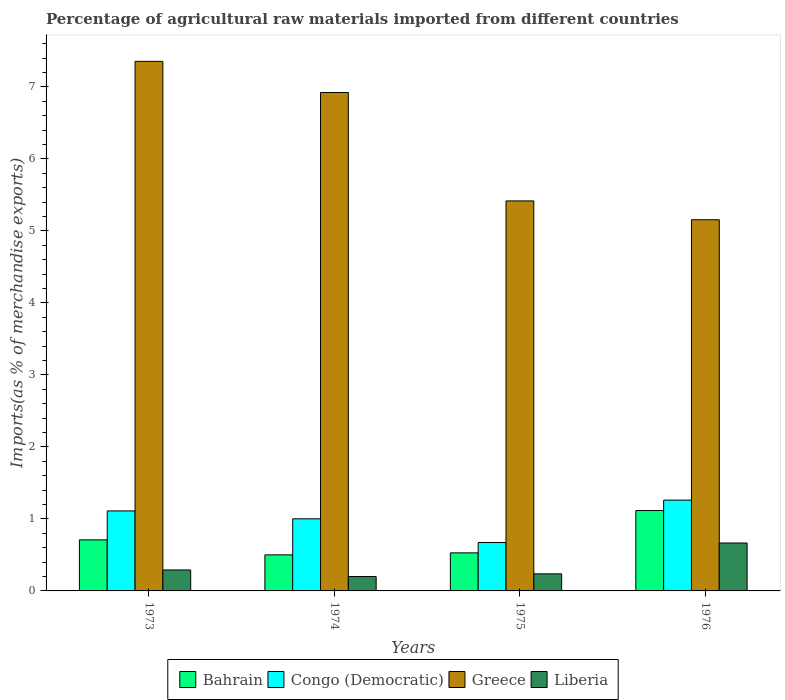How many different coloured bars are there?
Offer a very short reply. 4. Are the number of bars on each tick of the X-axis equal?
Offer a terse response. Yes. How many bars are there on the 1st tick from the left?
Ensure brevity in your answer.  4. In how many cases, is the number of bars for a given year not equal to the number of legend labels?
Provide a succinct answer. 0. What is the percentage of imports to different countries in Greece in 1973?
Your answer should be very brief. 7.35. Across all years, what is the maximum percentage of imports to different countries in Greece?
Give a very brief answer. 7.35. Across all years, what is the minimum percentage of imports to different countries in Bahrain?
Give a very brief answer. 0.5. In which year was the percentage of imports to different countries in Liberia maximum?
Your response must be concise. 1976. In which year was the percentage of imports to different countries in Liberia minimum?
Your answer should be very brief. 1974. What is the total percentage of imports to different countries in Congo (Democratic) in the graph?
Ensure brevity in your answer.  4.05. What is the difference between the percentage of imports to different countries in Liberia in 1973 and that in 1976?
Provide a short and direct response. -0.37. What is the difference between the percentage of imports to different countries in Congo (Democratic) in 1975 and the percentage of imports to different countries in Liberia in 1974?
Make the answer very short. 0.47. What is the average percentage of imports to different countries in Greece per year?
Give a very brief answer. 6.21. In the year 1976, what is the difference between the percentage of imports to different countries in Bahrain and percentage of imports to different countries in Liberia?
Make the answer very short. 0.45. In how many years, is the percentage of imports to different countries in Congo (Democratic) greater than 2.8 %?
Offer a very short reply. 0. What is the ratio of the percentage of imports to different countries in Congo (Democratic) in 1973 to that in 1976?
Provide a short and direct response. 0.88. What is the difference between the highest and the second highest percentage of imports to different countries in Congo (Democratic)?
Make the answer very short. 0.15. What is the difference between the highest and the lowest percentage of imports to different countries in Bahrain?
Ensure brevity in your answer.  0.62. Is the sum of the percentage of imports to different countries in Greece in 1973 and 1976 greater than the maximum percentage of imports to different countries in Liberia across all years?
Give a very brief answer. Yes. Is it the case that in every year, the sum of the percentage of imports to different countries in Greece and percentage of imports to different countries in Liberia is greater than the sum of percentage of imports to different countries in Bahrain and percentage of imports to different countries in Congo (Democratic)?
Your answer should be compact. Yes. What does the 2nd bar from the left in 1976 represents?
Make the answer very short. Congo (Democratic). What does the 1st bar from the right in 1973 represents?
Ensure brevity in your answer.  Liberia. How many bars are there?
Your response must be concise. 16. Are all the bars in the graph horizontal?
Your response must be concise. No. What is the difference between two consecutive major ticks on the Y-axis?
Your answer should be compact. 1. Does the graph contain any zero values?
Ensure brevity in your answer.  No. Does the graph contain grids?
Your response must be concise. No. How many legend labels are there?
Keep it short and to the point. 4. What is the title of the graph?
Ensure brevity in your answer.  Percentage of agricultural raw materials imported from different countries. What is the label or title of the X-axis?
Make the answer very short. Years. What is the label or title of the Y-axis?
Your response must be concise. Imports(as % of merchandise exports). What is the Imports(as % of merchandise exports) in Bahrain in 1973?
Offer a terse response. 0.71. What is the Imports(as % of merchandise exports) of Congo (Democratic) in 1973?
Make the answer very short. 1.11. What is the Imports(as % of merchandise exports) of Greece in 1973?
Offer a very short reply. 7.35. What is the Imports(as % of merchandise exports) of Liberia in 1973?
Your answer should be very brief. 0.29. What is the Imports(as % of merchandise exports) of Bahrain in 1974?
Offer a terse response. 0.5. What is the Imports(as % of merchandise exports) in Congo (Democratic) in 1974?
Make the answer very short. 1. What is the Imports(as % of merchandise exports) of Greece in 1974?
Your response must be concise. 6.92. What is the Imports(as % of merchandise exports) of Liberia in 1974?
Your answer should be very brief. 0.2. What is the Imports(as % of merchandise exports) of Bahrain in 1975?
Your response must be concise. 0.53. What is the Imports(as % of merchandise exports) in Congo (Democratic) in 1975?
Ensure brevity in your answer.  0.67. What is the Imports(as % of merchandise exports) of Greece in 1975?
Offer a terse response. 5.42. What is the Imports(as % of merchandise exports) in Liberia in 1975?
Keep it short and to the point. 0.24. What is the Imports(as % of merchandise exports) of Bahrain in 1976?
Make the answer very short. 1.12. What is the Imports(as % of merchandise exports) of Congo (Democratic) in 1976?
Make the answer very short. 1.26. What is the Imports(as % of merchandise exports) in Greece in 1976?
Your answer should be compact. 5.15. What is the Imports(as % of merchandise exports) of Liberia in 1976?
Give a very brief answer. 0.67. Across all years, what is the maximum Imports(as % of merchandise exports) of Bahrain?
Offer a very short reply. 1.12. Across all years, what is the maximum Imports(as % of merchandise exports) in Congo (Democratic)?
Make the answer very short. 1.26. Across all years, what is the maximum Imports(as % of merchandise exports) of Greece?
Provide a succinct answer. 7.35. Across all years, what is the maximum Imports(as % of merchandise exports) in Liberia?
Give a very brief answer. 0.67. Across all years, what is the minimum Imports(as % of merchandise exports) of Bahrain?
Provide a succinct answer. 0.5. Across all years, what is the minimum Imports(as % of merchandise exports) of Congo (Democratic)?
Offer a terse response. 0.67. Across all years, what is the minimum Imports(as % of merchandise exports) in Greece?
Give a very brief answer. 5.15. Across all years, what is the minimum Imports(as % of merchandise exports) in Liberia?
Offer a very short reply. 0.2. What is the total Imports(as % of merchandise exports) of Bahrain in the graph?
Give a very brief answer. 2.85. What is the total Imports(as % of merchandise exports) in Congo (Democratic) in the graph?
Your answer should be very brief. 4.05. What is the total Imports(as % of merchandise exports) of Greece in the graph?
Offer a terse response. 24.85. What is the total Imports(as % of merchandise exports) of Liberia in the graph?
Provide a short and direct response. 1.39. What is the difference between the Imports(as % of merchandise exports) in Bahrain in 1973 and that in 1974?
Your answer should be very brief. 0.21. What is the difference between the Imports(as % of merchandise exports) in Congo (Democratic) in 1973 and that in 1974?
Keep it short and to the point. 0.11. What is the difference between the Imports(as % of merchandise exports) of Greece in 1973 and that in 1974?
Your response must be concise. 0.43. What is the difference between the Imports(as % of merchandise exports) in Liberia in 1973 and that in 1974?
Your answer should be very brief. 0.09. What is the difference between the Imports(as % of merchandise exports) of Bahrain in 1973 and that in 1975?
Your answer should be compact. 0.18. What is the difference between the Imports(as % of merchandise exports) of Congo (Democratic) in 1973 and that in 1975?
Give a very brief answer. 0.44. What is the difference between the Imports(as % of merchandise exports) in Greece in 1973 and that in 1975?
Keep it short and to the point. 1.94. What is the difference between the Imports(as % of merchandise exports) of Liberia in 1973 and that in 1975?
Offer a terse response. 0.05. What is the difference between the Imports(as % of merchandise exports) in Bahrain in 1973 and that in 1976?
Provide a short and direct response. -0.41. What is the difference between the Imports(as % of merchandise exports) in Congo (Democratic) in 1973 and that in 1976?
Provide a short and direct response. -0.15. What is the difference between the Imports(as % of merchandise exports) in Greece in 1973 and that in 1976?
Your answer should be compact. 2.2. What is the difference between the Imports(as % of merchandise exports) in Liberia in 1973 and that in 1976?
Offer a terse response. -0.37. What is the difference between the Imports(as % of merchandise exports) in Bahrain in 1974 and that in 1975?
Provide a succinct answer. -0.03. What is the difference between the Imports(as % of merchandise exports) in Congo (Democratic) in 1974 and that in 1975?
Provide a short and direct response. 0.33. What is the difference between the Imports(as % of merchandise exports) of Greece in 1974 and that in 1975?
Keep it short and to the point. 1.51. What is the difference between the Imports(as % of merchandise exports) in Liberia in 1974 and that in 1975?
Offer a very short reply. -0.04. What is the difference between the Imports(as % of merchandise exports) in Bahrain in 1974 and that in 1976?
Your response must be concise. -0.62. What is the difference between the Imports(as % of merchandise exports) of Congo (Democratic) in 1974 and that in 1976?
Ensure brevity in your answer.  -0.26. What is the difference between the Imports(as % of merchandise exports) in Greece in 1974 and that in 1976?
Make the answer very short. 1.77. What is the difference between the Imports(as % of merchandise exports) of Liberia in 1974 and that in 1976?
Offer a very short reply. -0.47. What is the difference between the Imports(as % of merchandise exports) of Bahrain in 1975 and that in 1976?
Make the answer very short. -0.59. What is the difference between the Imports(as % of merchandise exports) of Congo (Democratic) in 1975 and that in 1976?
Make the answer very short. -0.59. What is the difference between the Imports(as % of merchandise exports) of Greece in 1975 and that in 1976?
Offer a terse response. 0.26. What is the difference between the Imports(as % of merchandise exports) in Liberia in 1975 and that in 1976?
Provide a short and direct response. -0.43. What is the difference between the Imports(as % of merchandise exports) in Bahrain in 1973 and the Imports(as % of merchandise exports) in Congo (Democratic) in 1974?
Your answer should be compact. -0.29. What is the difference between the Imports(as % of merchandise exports) in Bahrain in 1973 and the Imports(as % of merchandise exports) in Greece in 1974?
Your response must be concise. -6.21. What is the difference between the Imports(as % of merchandise exports) of Bahrain in 1973 and the Imports(as % of merchandise exports) of Liberia in 1974?
Your answer should be compact. 0.51. What is the difference between the Imports(as % of merchandise exports) of Congo (Democratic) in 1973 and the Imports(as % of merchandise exports) of Greece in 1974?
Make the answer very short. -5.81. What is the difference between the Imports(as % of merchandise exports) of Congo (Democratic) in 1973 and the Imports(as % of merchandise exports) of Liberia in 1974?
Provide a succinct answer. 0.91. What is the difference between the Imports(as % of merchandise exports) of Greece in 1973 and the Imports(as % of merchandise exports) of Liberia in 1974?
Give a very brief answer. 7.15. What is the difference between the Imports(as % of merchandise exports) in Bahrain in 1973 and the Imports(as % of merchandise exports) in Congo (Democratic) in 1975?
Provide a succinct answer. 0.04. What is the difference between the Imports(as % of merchandise exports) in Bahrain in 1973 and the Imports(as % of merchandise exports) in Greece in 1975?
Provide a short and direct response. -4.71. What is the difference between the Imports(as % of merchandise exports) of Bahrain in 1973 and the Imports(as % of merchandise exports) of Liberia in 1975?
Give a very brief answer. 0.47. What is the difference between the Imports(as % of merchandise exports) in Congo (Democratic) in 1973 and the Imports(as % of merchandise exports) in Greece in 1975?
Ensure brevity in your answer.  -4.31. What is the difference between the Imports(as % of merchandise exports) of Congo (Democratic) in 1973 and the Imports(as % of merchandise exports) of Liberia in 1975?
Keep it short and to the point. 0.87. What is the difference between the Imports(as % of merchandise exports) in Greece in 1973 and the Imports(as % of merchandise exports) in Liberia in 1975?
Offer a terse response. 7.12. What is the difference between the Imports(as % of merchandise exports) in Bahrain in 1973 and the Imports(as % of merchandise exports) in Congo (Democratic) in 1976?
Provide a succinct answer. -0.55. What is the difference between the Imports(as % of merchandise exports) of Bahrain in 1973 and the Imports(as % of merchandise exports) of Greece in 1976?
Provide a short and direct response. -4.45. What is the difference between the Imports(as % of merchandise exports) of Bahrain in 1973 and the Imports(as % of merchandise exports) of Liberia in 1976?
Your response must be concise. 0.04. What is the difference between the Imports(as % of merchandise exports) of Congo (Democratic) in 1973 and the Imports(as % of merchandise exports) of Greece in 1976?
Keep it short and to the point. -4.04. What is the difference between the Imports(as % of merchandise exports) in Congo (Democratic) in 1973 and the Imports(as % of merchandise exports) in Liberia in 1976?
Make the answer very short. 0.45. What is the difference between the Imports(as % of merchandise exports) of Greece in 1973 and the Imports(as % of merchandise exports) of Liberia in 1976?
Provide a succinct answer. 6.69. What is the difference between the Imports(as % of merchandise exports) of Bahrain in 1974 and the Imports(as % of merchandise exports) of Congo (Democratic) in 1975?
Provide a succinct answer. -0.17. What is the difference between the Imports(as % of merchandise exports) of Bahrain in 1974 and the Imports(as % of merchandise exports) of Greece in 1975?
Offer a very short reply. -4.92. What is the difference between the Imports(as % of merchandise exports) in Bahrain in 1974 and the Imports(as % of merchandise exports) in Liberia in 1975?
Keep it short and to the point. 0.26. What is the difference between the Imports(as % of merchandise exports) in Congo (Democratic) in 1974 and the Imports(as % of merchandise exports) in Greece in 1975?
Your response must be concise. -4.41. What is the difference between the Imports(as % of merchandise exports) of Congo (Democratic) in 1974 and the Imports(as % of merchandise exports) of Liberia in 1975?
Make the answer very short. 0.76. What is the difference between the Imports(as % of merchandise exports) in Greece in 1974 and the Imports(as % of merchandise exports) in Liberia in 1975?
Offer a terse response. 6.68. What is the difference between the Imports(as % of merchandise exports) in Bahrain in 1974 and the Imports(as % of merchandise exports) in Congo (Democratic) in 1976?
Offer a very short reply. -0.76. What is the difference between the Imports(as % of merchandise exports) of Bahrain in 1974 and the Imports(as % of merchandise exports) of Greece in 1976?
Your response must be concise. -4.65. What is the difference between the Imports(as % of merchandise exports) of Bahrain in 1974 and the Imports(as % of merchandise exports) of Liberia in 1976?
Keep it short and to the point. -0.16. What is the difference between the Imports(as % of merchandise exports) of Congo (Democratic) in 1974 and the Imports(as % of merchandise exports) of Greece in 1976?
Your answer should be very brief. -4.15. What is the difference between the Imports(as % of merchandise exports) of Congo (Democratic) in 1974 and the Imports(as % of merchandise exports) of Liberia in 1976?
Provide a short and direct response. 0.34. What is the difference between the Imports(as % of merchandise exports) in Greece in 1974 and the Imports(as % of merchandise exports) in Liberia in 1976?
Ensure brevity in your answer.  6.26. What is the difference between the Imports(as % of merchandise exports) of Bahrain in 1975 and the Imports(as % of merchandise exports) of Congo (Democratic) in 1976?
Provide a short and direct response. -0.73. What is the difference between the Imports(as % of merchandise exports) of Bahrain in 1975 and the Imports(as % of merchandise exports) of Greece in 1976?
Your answer should be very brief. -4.63. What is the difference between the Imports(as % of merchandise exports) in Bahrain in 1975 and the Imports(as % of merchandise exports) in Liberia in 1976?
Offer a terse response. -0.14. What is the difference between the Imports(as % of merchandise exports) in Congo (Democratic) in 1975 and the Imports(as % of merchandise exports) in Greece in 1976?
Ensure brevity in your answer.  -4.48. What is the difference between the Imports(as % of merchandise exports) of Congo (Democratic) in 1975 and the Imports(as % of merchandise exports) of Liberia in 1976?
Make the answer very short. 0.01. What is the difference between the Imports(as % of merchandise exports) in Greece in 1975 and the Imports(as % of merchandise exports) in Liberia in 1976?
Offer a very short reply. 4.75. What is the average Imports(as % of merchandise exports) of Bahrain per year?
Give a very brief answer. 0.71. What is the average Imports(as % of merchandise exports) of Congo (Democratic) per year?
Offer a very short reply. 1.01. What is the average Imports(as % of merchandise exports) in Greece per year?
Provide a short and direct response. 6.21. What is the average Imports(as % of merchandise exports) in Liberia per year?
Ensure brevity in your answer.  0.35. In the year 1973, what is the difference between the Imports(as % of merchandise exports) in Bahrain and Imports(as % of merchandise exports) in Congo (Democratic)?
Keep it short and to the point. -0.4. In the year 1973, what is the difference between the Imports(as % of merchandise exports) of Bahrain and Imports(as % of merchandise exports) of Greece?
Your response must be concise. -6.65. In the year 1973, what is the difference between the Imports(as % of merchandise exports) of Bahrain and Imports(as % of merchandise exports) of Liberia?
Make the answer very short. 0.42. In the year 1973, what is the difference between the Imports(as % of merchandise exports) of Congo (Democratic) and Imports(as % of merchandise exports) of Greece?
Give a very brief answer. -6.24. In the year 1973, what is the difference between the Imports(as % of merchandise exports) of Congo (Democratic) and Imports(as % of merchandise exports) of Liberia?
Your answer should be very brief. 0.82. In the year 1973, what is the difference between the Imports(as % of merchandise exports) of Greece and Imports(as % of merchandise exports) of Liberia?
Your response must be concise. 7.06. In the year 1974, what is the difference between the Imports(as % of merchandise exports) of Bahrain and Imports(as % of merchandise exports) of Congo (Democratic)?
Your answer should be compact. -0.5. In the year 1974, what is the difference between the Imports(as % of merchandise exports) in Bahrain and Imports(as % of merchandise exports) in Greece?
Your answer should be compact. -6.42. In the year 1974, what is the difference between the Imports(as % of merchandise exports) of Bahrain and Imports(as % of merchandise exports) of Liberia?
Offer a very short reply. 0.3. In the year 1974, what is the difference between the Imports(as % of merchandise exports) in Congo (Democratic) and Imports(as % of merchandise exports) in Greece?
Provide a succinct answer. -5.92. In the year 1974, what is the difference between the Imports(as % of merchandise exports) of Congo (Democratic) and Imports(as % of merchandise exports) of Liberia?
Your answer should be compact. 0.8. In the year 1974, what is the difference between the Imports(as % of merchandise exports) of Greece and Imports(as % of merchandise exports) of Liberia?
Make the answer very short. 6.72. In the year 1975, what is the difference between the Imports(as % of merchandise exports) of Bahrain and Imports(as % of merchandise exports) of Congo (Democratic)?
Give a very brief answer. -0.14. In the year 1975, what is the difference between the Imports(as % of merchandise exports) of Bahrain and Imports(as % of merchandise exports) of Greece?
Make the answer very short. -4.89. In the year 1975, what is the difference between the Imports(as % of merchandise exports) in Bahrain and Imports(as % of merchandise exports) in Liberia?
Provide a succinct answer. 0.29. In the year 1975, what is the difference between the Imports(as % of merchandise exports) of Congo (Democratic) and Imports(as % of merchandise exports) of Greece?
Your answer should be compact. -4.74. In the year 1975, what is the difference between the Imports(as % of merchandise exports) of Congo (Democratic) and Imports(as % of merchandise exports) of Liberia?
Offer a very short reply. 0.44. In the year 1975, what is the difference between the Imports(as % of merchandise exports) of Greece and Imports(as % of merchandise exports) of Liberia?
Offer a very short reply. 5.18. In the year 1976, what is the difference between the Imports(as % of merchandise exports) of Bahrain and Imports(as % of merchandise exports) of Congo (Democratic)?
Offer a very short reply. -0.14. In the year 1976, what is the difference between the Imports(as % of merchandise exports) in Bahrain and Imports(as % of merchandise exports) in Greece?
Provide a succinct answer. -4.04. In the year 1976, what is the difference between the Imports(as % of merchandise exports) in Bahrain and Imports(as % of merchandise exports) in Liberia?
Offer a very short reply. 0.45. In the year 1976, what is the difference between the Imports(as % of merchandise exports) in Congo (Democratic) and Imports(as % of merchandise exports) in Greece?
Your answer should be very brief. -3.89. In the year 1976, what is the difference between the Imports(as % of merchandise exports) in Congo (Democratic) and Imports(as % of merchandise exports) in Liberia?
Give a very brief answer. 0.6. In the year 1976, what is the difference between the Imports(as % of merchandise exports) in Greece and Imports(as % of merchandise exports) in Liberia?
Provide a succinct answer. 4.49. What is the ratio of the Imports(as % of merchandise exports) of Bahrain in 1973 to that in 1974?
Your answer should be compact. 1.42. What is the ratio of the Imports(as % of merchandise exports) in Congo (Democratic) in 1973 to that in 1974?
Offer a very short reply. 1.11. What is the ratio of the Imports(as % of merchandise exports) in Liberia in 1973 to that in 1974?
Offer a very short reply. 1.46. What is the ratio of the Imports(as % of merchandise exports) in Bahrain in 1973 to that in 1975?
Provide a short and direct response. 1.34. What is the ratio of the Imports(as % of merchandise exports) of Congo (Democratic) in 1973 to that in 1975?
Offer a very short reply. 1.65. What is the ratio of the Imports(as % of merchandise exports) of Greece in 1973 to that in 1975?
Offer a very short reply. 1.36. What is the ratio of the Imports(as % of merchandise exports) in Liberia in 1973 to that in 1975?
Your answer should be very brief. 1.23. What is the ratio of the Imports(as % of merchandise exports) in Bahrain in 1973 to that in 1976?
Offer a terse response. 0.64. What is the ratio of the Imports(as % of merchandise exports) in Congo (Democratic) in 1973 to that in 1976?
Provide a succinct answer. 0.88. What is the ratio of the Imports(as % of merchandise exports) of Greece in 1973 to that in 1976?
Keep it short and to the point. 1.43. What is the ratio of the Imports(as % of merchandise exports) in Liberia in 1973 to that in 1976?
Offer a terse response. 0.44. What is the ratio of the Imports(as % of merchandise exports) of Bahrain in 1974 to that in 1975?
Give a very brief answer. 0.95. What is the ratio of the Imports(as % of merchandise exports) in Congo (Democratic) in 1974 to that in 1975?
Your answer should be compact. 1.49. What is the ratio of the Imports(as % of merchandise exports) in Greece in 1974 to that in 1975?
Provide a succinct answer. 1.28. What is the ratio of the Imports(as % of merchandise exports) in Liberia in 1974 to that in 1975?
Your answer should be very brief. 0.84. What is the ratio of the Imports(as % of merchandise exports) of Bahrain in 1974 to that in 1976?
Make the answer very short. 0.45. What is the ratio of the Imports(as % of merchandise exports) of Congo (Democratic) in 1974 to that in 1976?
Provide a succinct answer. 0.79. What is the ratio of the Imports(as % of merchandise exports) of Greece in 1974 to that in 1976?
Give a very brief answer. 1.34. What is the ratio of the Imports(as % of merchandise exports) in Liberia in 1974 to that in 1976?
Offer a terse response. 0.3. What is the ratio of the Imports(as % of merchandise exports) of Bahrain in 1975 to that in 1976?
Ensure brevity in your answer.  0.47. What is the ratio of the Imports(as % of merchandise exports) of Congo (Democratic) in 1975 to that in 1976?
Offer a very short reply. 0.53. What is the ratio of the Imports(as % of merchandise exports) of Greece in 1975 to that in 1976?
Ensure brevity in your answer.  1.05. What is the ratio of the Imports(as % of merchandise exports) of Liberia in 1975 to that in 1976?
Provide a succinct answer. 0.36. What is the difference between the highest and the second highest Imports(as % of merchandise exports) of Bahrain?
Your answer should be compact. 0.41. What is the difference between the highest and the second highest Imports(as % of merchandise exports) in Congo (Democratic)?
Your answer should be very brief. 0.15. What is the difference between the highest and the second highest Imports(as % of merchandise exports) in Greece?
Make the answer very short. 0.43. What is the difference between the highest and the second highest Imports(as % of merchandise exports) in Liberia?
Your response must be concise. 0.37. What is the difference between the highest and the lowest Imports(as % of merchandise exports) in Bahrain?
Offer a very short reply. 0.62. What is the difference between the highest and the lowest Imports(as % of merchandise exports) in Congo (Democratic)?
Keep it short and to the point. 0.59. What is the difference between the highest and the lowest Imports(as % of merchandise exports) in Greece?
Ensure brevity in your answer.  2.2. What is the difference between the highest and the lowest Imports(as % of merchandise exports) of Liberia?
Your response must be concise. 0.47. 